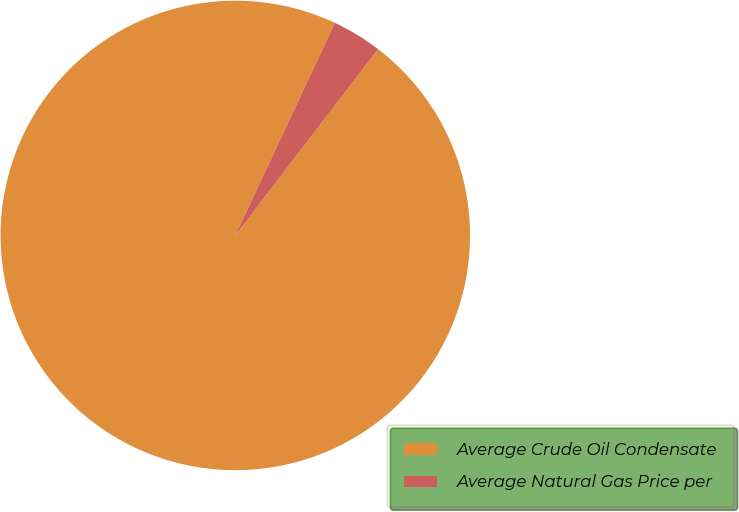Convert chart to OTSL. <chart><loc_0><loc_0><loc_500><loc_500><pie_chart><fcel>Average Crude Oil Condensate<fcel>Average Natural Gas Price per<nl><fcel>96.56%<fcel>3.44%<nl></chart> 